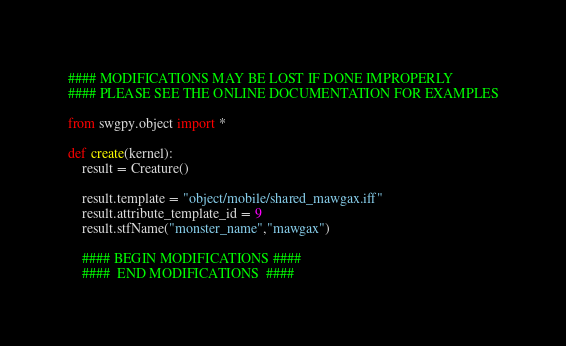<code> <loc_0><loc_0><loc_500><loc_500><_Python_>#### MODIFICATIONS MAY BE LOST IF DONE IMPROPERLY
#### PLEASE SEE THE ONLINE DOCUMENTATION FOR EXAMPLES

from swgpy.object import *	

def create(kernel):
	result = Creature()

	result.template = "object/mobile/shared_mawgax.iff"
	result.attribute_template_id = 9
	result.stfName("monster_name","mawgax")		
	
	#### BEGIN MODIFICATIONS ####
	####  END MODIFICATIONS  ####</code> 